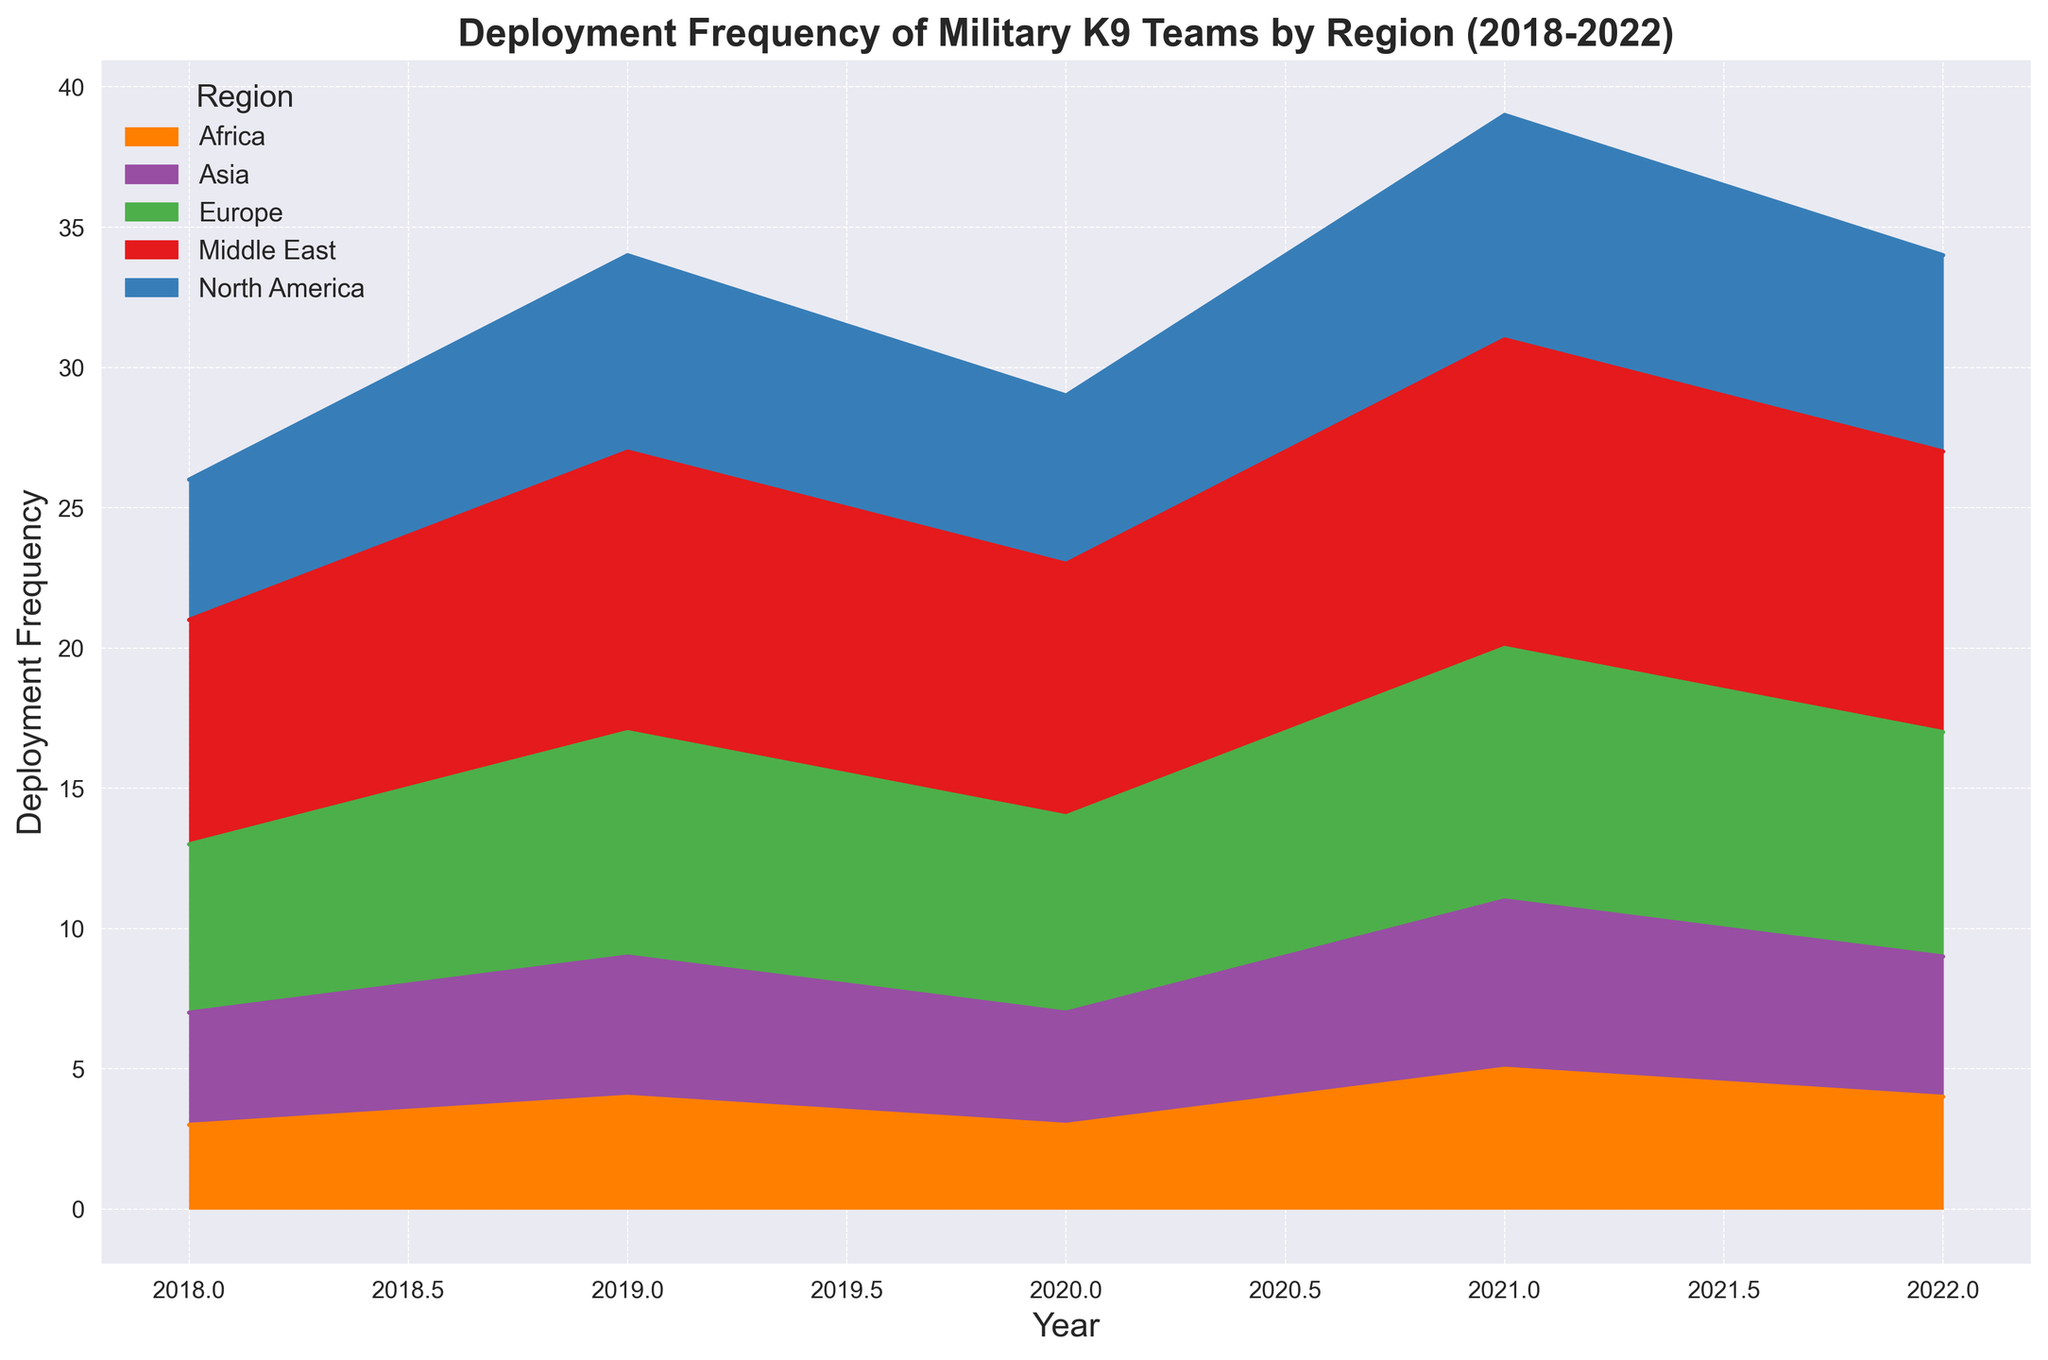What's the average deployment frequency for North America from 2018 to 2022? The deployment frequencies for North America are 5, 7, 6, 8, and 7 from 2018 to 2022. Sum them up (5 + 7 + 6 + 8 + 7 = 33) and divide by the number of years (33 / 5 = 6.6).
Answer: 6.6 Which region had the highest deployment frequency in 2021? Looking at the highest point in 2021, the region with the highest deployment frequency is the Middle East, with 11 deployments.
Answer: Middle East What's the total deployment frequency for the Middle East over the five years? The deployment frequencies for the Middle East are 8, 10, 9, 11, and 10 from 2018 to 2022. Sum them up (8 + 10 + 9 + 11 + 10 = 48).
Answer: 48 Compare the deployment frequency in 2022 between Europe and Asia. Which region had a higher frequency? In 2022, Europe had a deployment frequency of 8, while Asia had a frequency of 5. Europe had the higher frequency.
Answer: Europe Which region shows a consistent year-on-year increase in deployment frequency over this period? The region that shows a consistent year-on-year increase in deployment frequency is the Middle East (2018: 8, 2019: 10, 2020: 9, 2021: 11, 2022: 10).
Answer: Middle East Between 2019 and 2020, which region saw a decline in deployment frequency? North America (7 to 6), Europe (8 to 7), and Middle East (10 to 9) saw declines in deployment frequency between 2019 and 2020.
Answer: North America, Europe, and Middle East How did the deployment frequency change for Africa between 2019 and 2021? In 2019, Africa's deployment frequency was 4. It decreased to 3 in 2020 and then increased to 5 in 2021. So it first decreased and then increased.
Answer: Decreased and then increased What is the combined deployment frequency of Europe and North America in 2020? North America had a deployment frequency of 6 and Europe had 7 in 2020. Combined, they total (6 + 7 = 13).
Answer: 13 Identify the region with the lowest deployment frequency in 2018. In 2018, Africa had the lowest deployment frequency with 3.
Answer: Africa Which region's deployment frequency was unchanged from 2021 to 2022? Both Europe and the Middle East had deployment frequencies that remained unchanged from 2021 to 2022 (Europe: 9 to 8, Middle East: 11 to 10).
Answer: None 